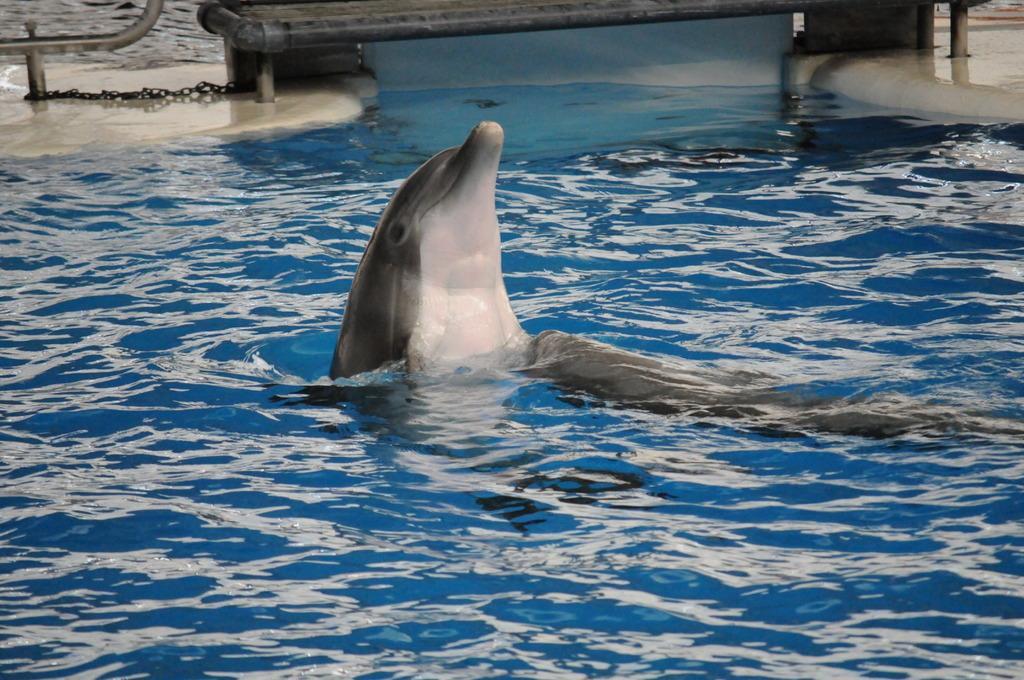Describe this image in one or two sentences. In the image we can see water, in the water we can see a dolphin. 